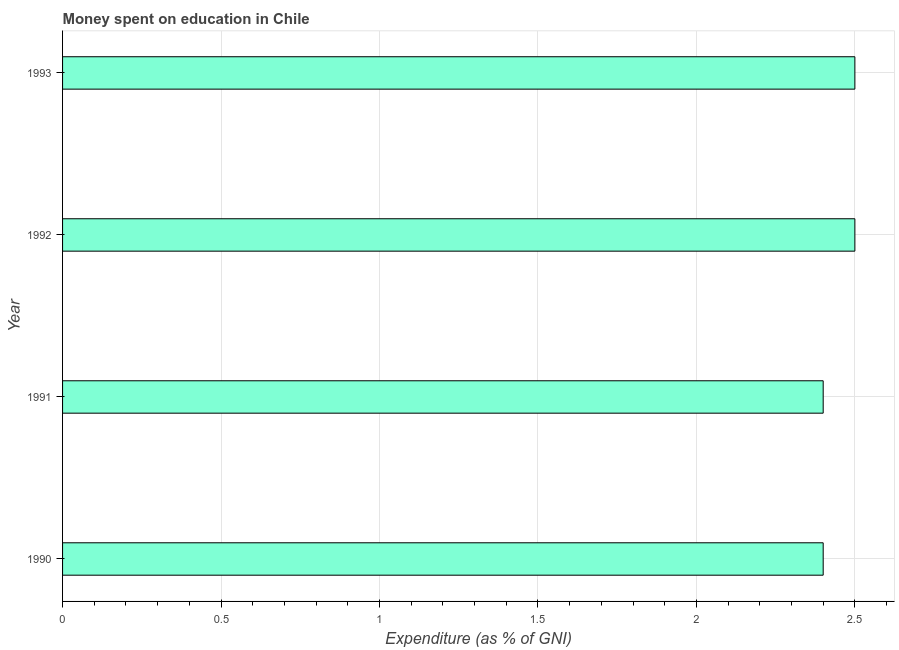What is the title of the graph?
Ensure brevity in your answer.  Money spent on education in Chile. What is the label or title of the X-axis?
Make the answer very short. Expenditure (as % of GNI). What is the label or title of the Y-axis?
Ensure brevity in your answer.  Year. In which year was the expenditure on education maximum?
Make the answer very short. 1992. What is the difference between the expenditure on education in 1990 and 1991?
Make the answer very short. 0. What is the average expenditure on education per year?
Provide a succinct answer. 2.45. What is the median expenditure on education?
Provide a succinct answer. 2.45. Do a majority of the years between 1990 and 1992 (inclusive) have expenditure on education greater than 1.4 %?
Make the answer very short. Yes. Is the expenditure on education in 1991 less than that in 1993?
Your answer should be compact. Yes. What is the difference between the highest and the second highest expenditure on education?
Your answer should be compact. 0. How many bars are there?
Provide a short and direct response. 4. Are all the bars in the graph horizontal?
Provide a short and direct response. Yes. Are the values on the major ticks of X-axis written in scientific E-notation?
Provide a short and direct response. No. What is the difference between the Expenditure (as % of GNI) in 1990 and 1993?
Ensure brevity in your answer.  -0.1. What is the difference between the Expenditure (as % of GNI) in 1991 and 1992?
Make the answer very short. -0.1. What is the difference between the Expenditure (as % of GNI) in 1992 and 1993?
Give a very brief answer. 0. What is the ratio of the Expenditure (as % of GNI) in 1990 to that in 1991?
Offer a very short reply. 1. What is the ratio of the Expenditure (as % of GNI) in 1991 to that in 1992?
Give a very brief answer. 0.96. What is the ratio of the Expenditure (as % of GNI) in 1991 to that in 1993?
Keep it short and to the point. 0.96. 